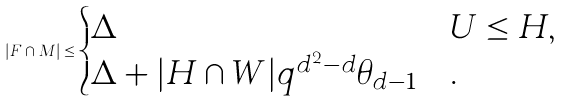<formula> <loc_0><loc_0><loc_500><loc_500>| F \cap M | \leq \begin{cases} \Delta & U \leq H , \\ \Delta + | H \cap W | q ^ { d ^ { 2 } - d } \theta _ { d - 1 } & . \end{cases}</formula> 